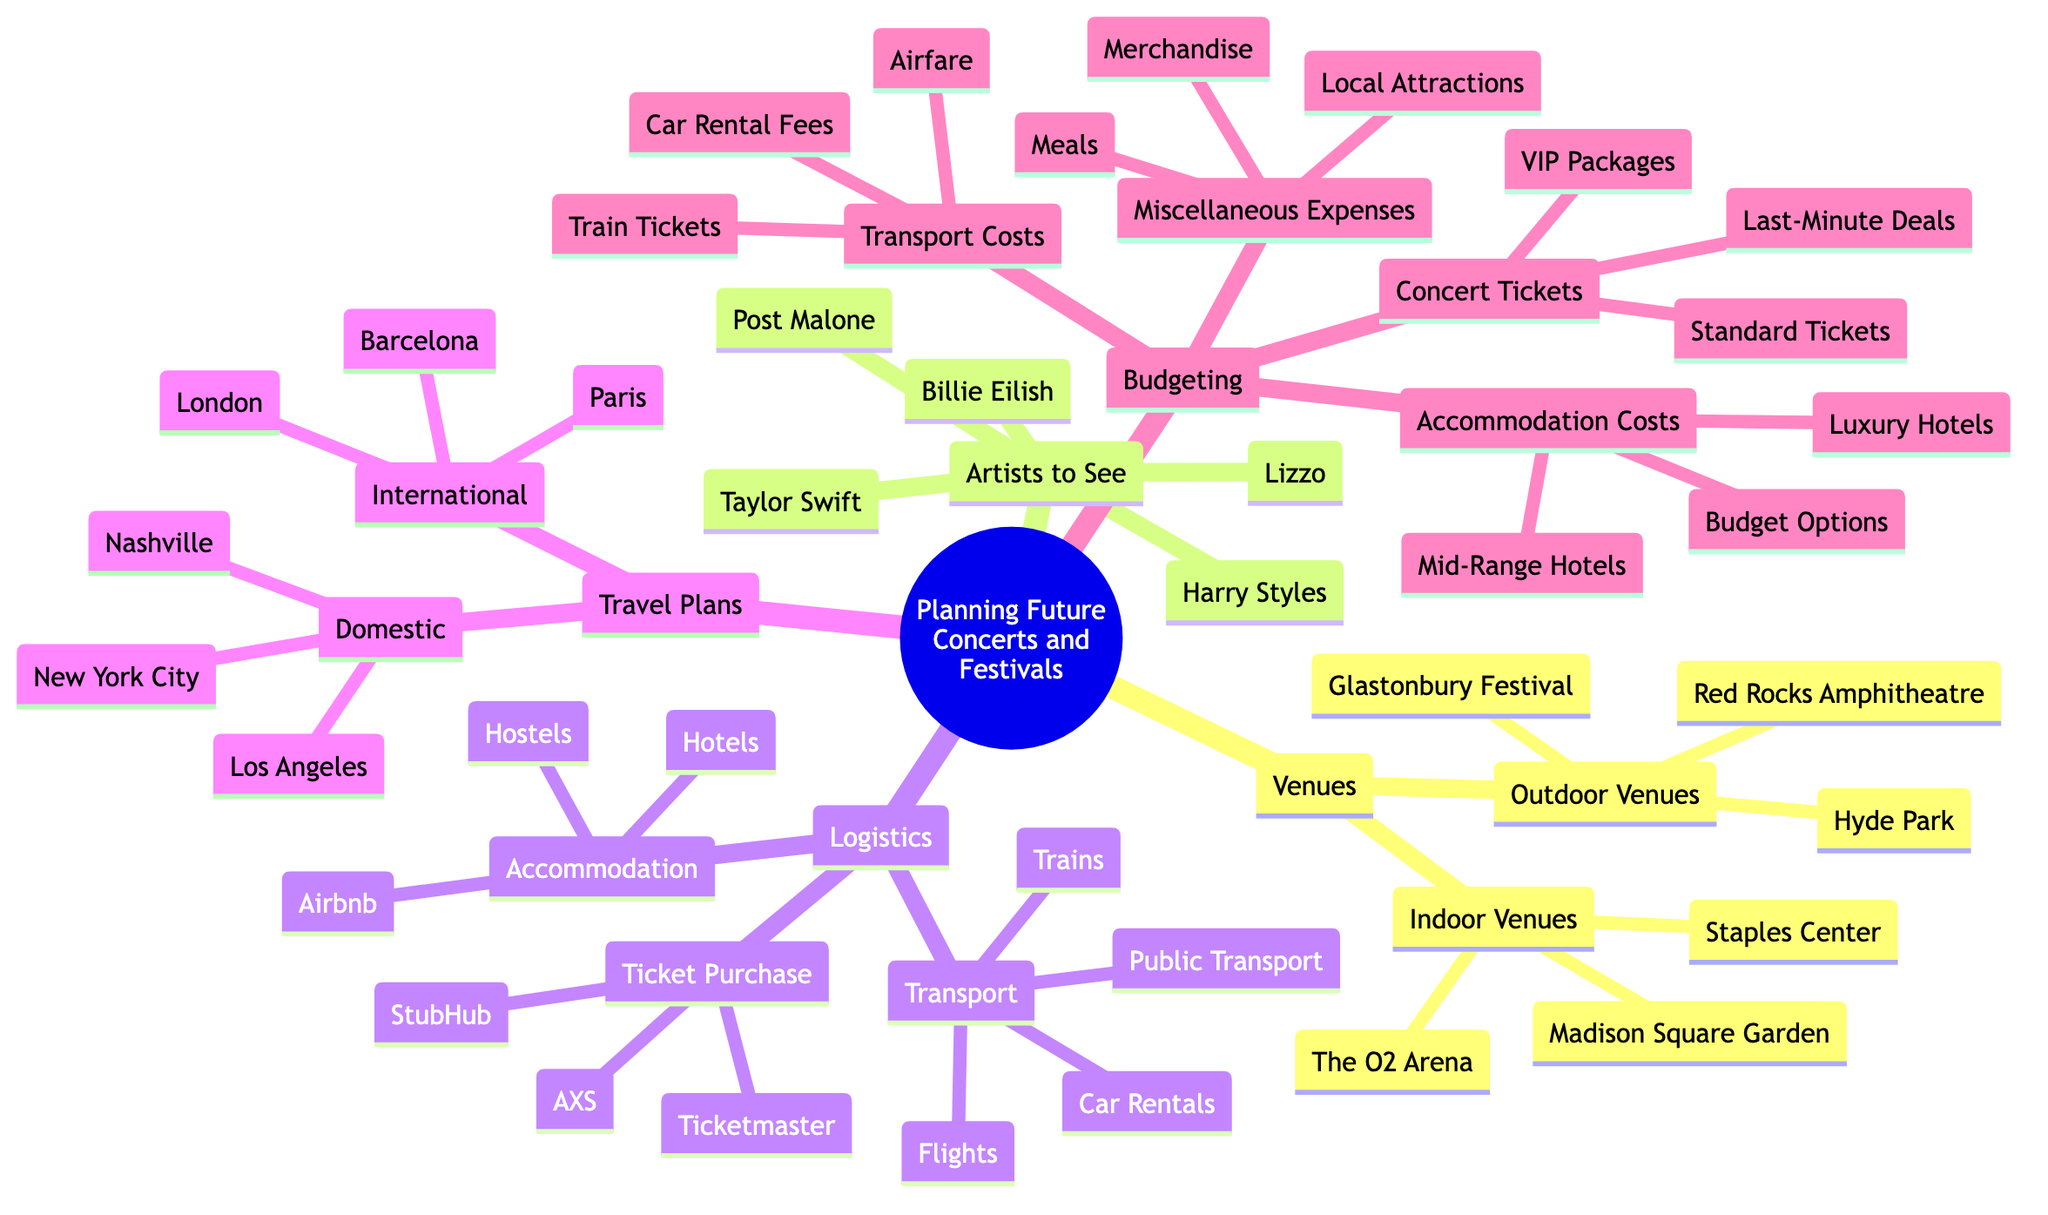What are three indoor venues listed in the diagram? The diagram lists "Indoor Venues" under the "Venues" category, and the specific venues mentioned are Madison Square Garden, The O2 Arena, and Staples Center.
Answer: Madison Square Garden, The O2 Arena, Staples Center How many artists are listed as options to see? The "Artists to See" section contains five names: Harry Styles, Taylor Swift, Billie Eilish, Post Malone, and Lizzo. Counting these gives a total of five artists.
Answer: 5 Which outdoor venue is mentioned last in the diagram? In the "Outdoor Venues" section, the venues are listed as Glastonbury Festival, Red Rocks Amphitheatre, and Hyde Park. The last venue mentioned is Hyde Park.
Answer: Hyde Park What are the three categories under Logistics? The "Logistics" section includes three categories: Ticket Purchase, Accommodation, and Transport. Counting these gives a total of three categories.
Answer: Ticket Purchase, Accommodation, Transport Which city is listed under Travel Plans as a domestic option? In the "Travel Plans" section, under Domestic, there are three cities: New York City, Los Angeles, and Nashville. Any of these can be a valid answer, but since the question seeks to identify one, we can refer to New York City as the first mentioned.
Answer: New York City What types of accommodation costs are mentioned in Budgeting? The "Accommodation Costs" subsection includes Luxury Hotels, Mid-Range Hotels, and Budget Options. Listing these provides insight into the types of accommodations one might consider.
Answer: Luxury Hotels, Mid-Range Hotels, Budget Options Which ticket purchase platform is listed second? The "Ticket Purchase" section lists Ticketmaster, StubHub, and AXS as platforms. StubHub is the second one mentioned in this list.
Answer: StubHub How many international cities are listed in Travel Plans? Under the "Travel Plans" section, there are three international cities mentioned: London, Paris, and Barcelona. Counting these gives a total of three international cities.
Answer: 3 